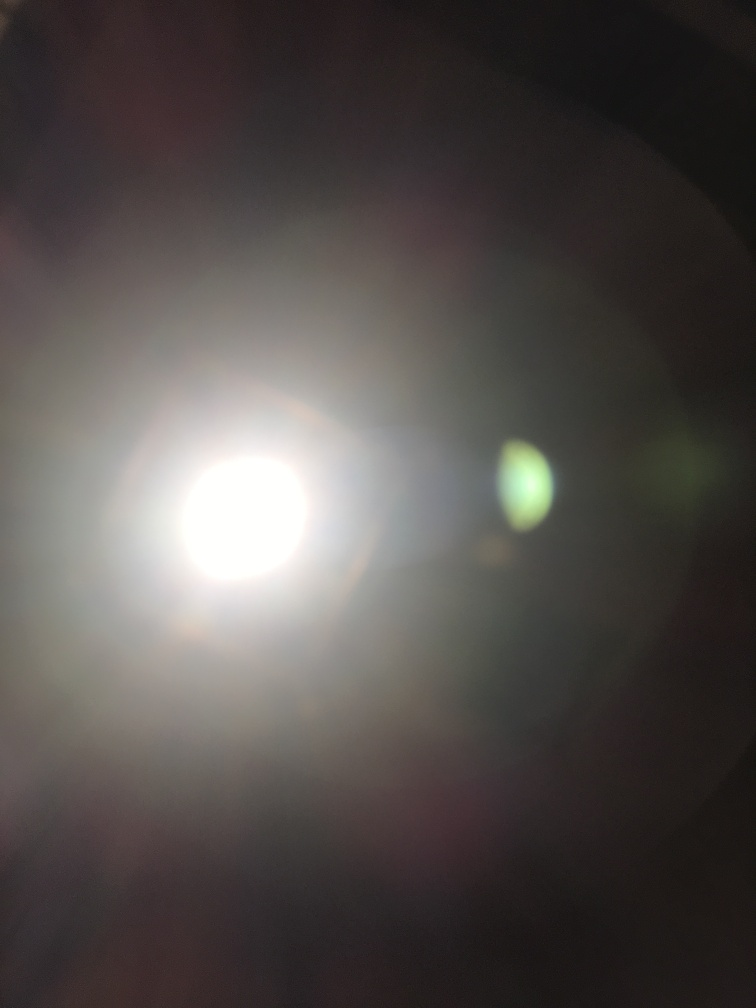What is the overall quality of this image?
A. Good
B. Very poor
C. Average
D. Excellent The overall quality of the image is quite poor due to its overexposed elements and lack of discernible content. This extreme brightness obscures any potential details, making it difficult to ascertain what the subject may have been. Typically, a high-quality image would have clear focus, balanced lighting, and visible subjects, which this image lacks. 